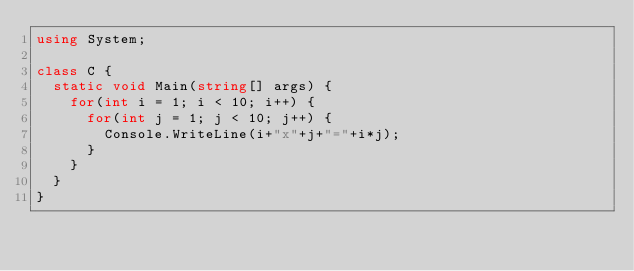<code> <loc_0><loc_0><loc_500><loc_500><_C#_>using System;

class C {
  static void Main(string[] args) {
    for(int i = 1; i < 10; i++) {
      for(int j = 1; j < 10; j++) {
        Console.WriteLine(i+"x"+j+"="+i*j);
      }
    }
  }
}</code> 